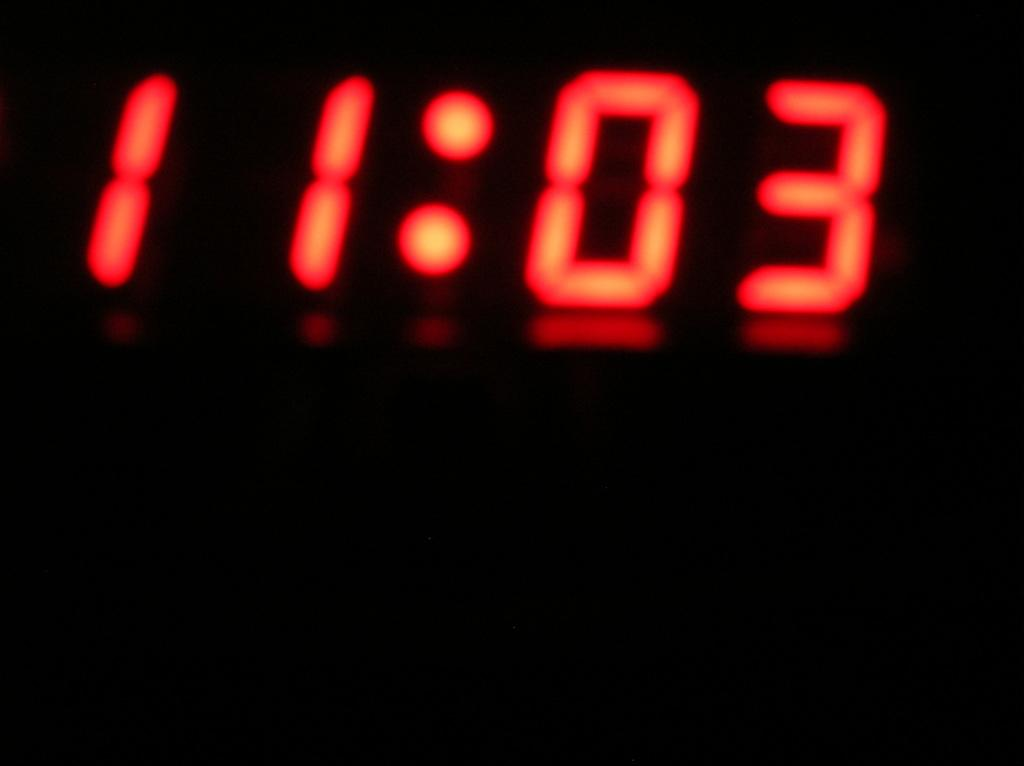<image>
Offer a succinct explanation of the picture presented. a digital clock in the dark that reads 11:03 